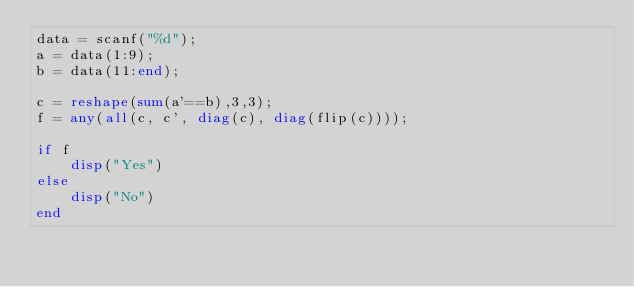Convert code to text. <code><loc_0><loc_0><loc_500><loc_500><_Octave_>data = scanf("%d");
a = data(1:9);
b = data(11:end);

c = reshape(sum(a'==b),3,3);
f = any(all(c, c', diag(c), diag(flip(c))));

if f
    disp("Yes")
else
    disp("No")
end</code> 